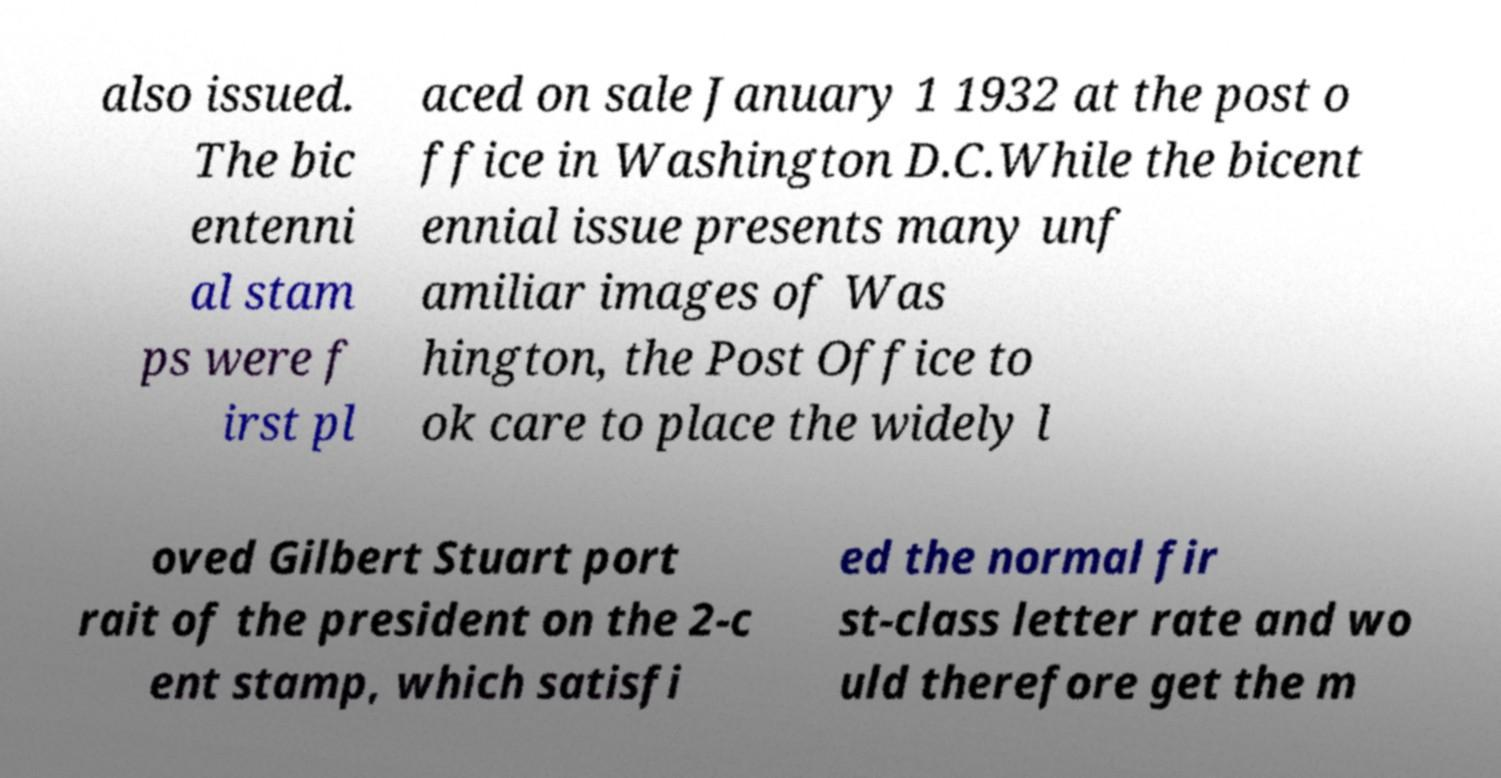Could you extract and type out the text from this image? also issued. The bic entenni al stam ps were f irst pl aced on sale January 1 1932 at the post o ffice in Washington D.C.While the bicent ennial issue presents many unf amiliar images of Was hington, the Post Office to ok care to place the widely l oved Gilbert Stuart port rait of the president on the 2-c ent stamp, which satisfi ed the normal fir st-class letter rate and wo uld therefore get the m 